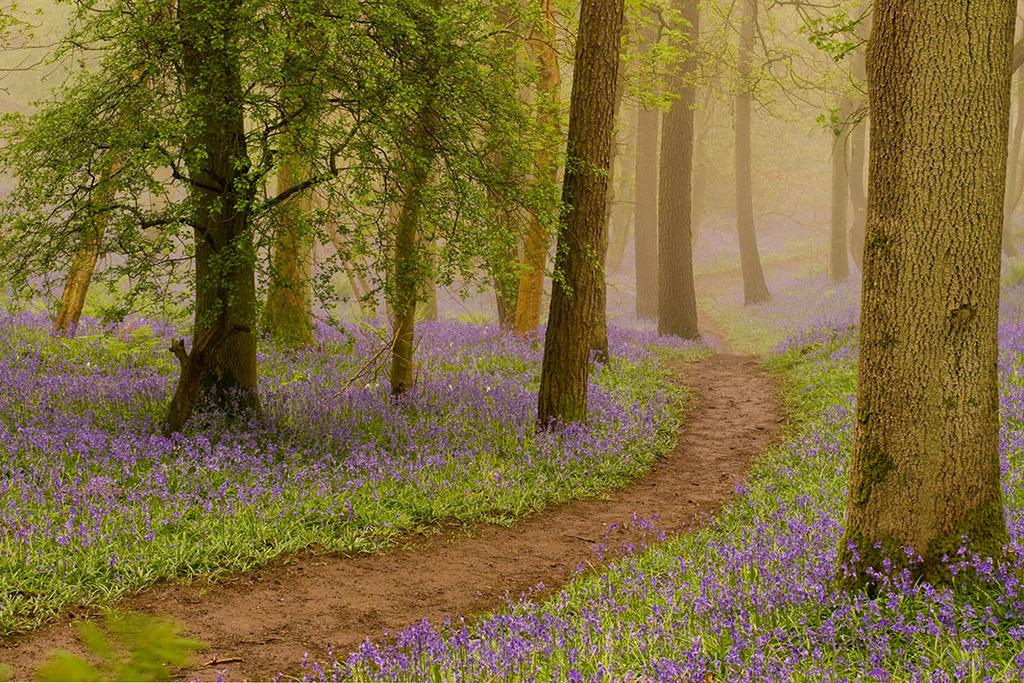What type of flora can be seen in the image? There are flowers, plants, and trees in the image. Can you describe the different types of vegetation present? The image contains flowers, plants, and trees. What is the natural environment depicted in the image? The image features a variety of vegetation, including flowers, plants, and trees. How many pigs are sitting on the seat in the image? There are no pigs or seats present in the image; it features flowers, plants, and trees. 